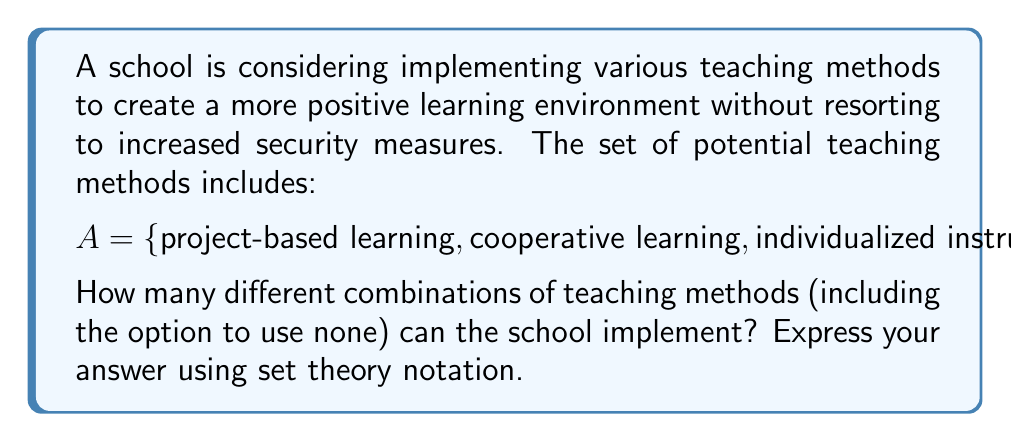Can you solve this math problem? To solve this problem, we need to apply the concept of power sets.

1) First, let's recall what a power set is:
   The power set of a set A, denoted as P(A), is the set of all subsets of A, including the empty set and A itself.

2) For a set with n elements, the number of elements in its power set is given by 2^n.

3) In this case, our set A has 4 elements:
   |A| = 4

4) Therefore, the number of elements in the power set of A is:
   |P(A)| = 2^4 = 16

5) We can express this using set theory notation as:
   |P(A)| = 2^|A| = 2^4

This means the school can implement 16 different combinations of teaching methods, including:
- Using no methods (empty set)
- Using any single method (4 possibilities)
- Using any combination of two methods (6 possibilities)
- Using any combination of three methods (4 possibilities)
- Using all four methods (1 possibility)

Each of these combinations represents a different approach to creating a positive learning environment without turning the school into a fortress-like structure.
Answer: $$|P(A)| = 2^{|A|} = 2^4 = 16$$ 